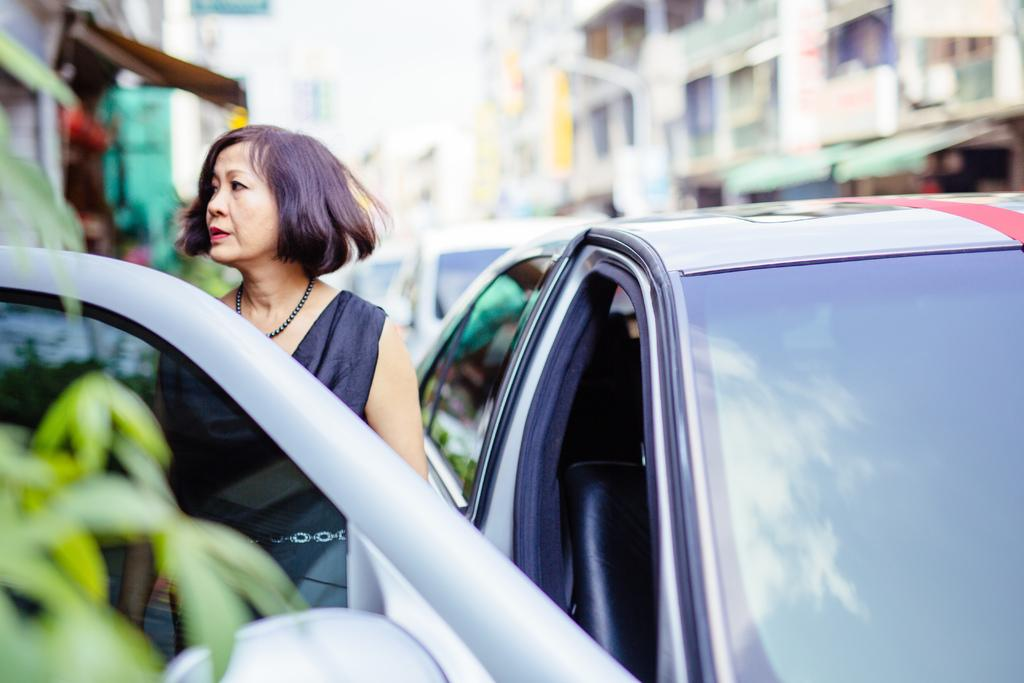What types of objects are present in the image? There are vehicles, a person, leaves, and buildings in the image. Can you describe the person in the image? There is a person in the image, but no specific details about their appearance or actions are provided. What can be seen in the background of the image? The background of the image is blurred, so it is difficult to make out specific details. Where is the dog in the image? There is no dog present in the image. What type of rock can be seen in the image? There is no rock present in the image. 